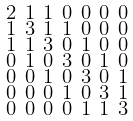<formula> <loc_0><loc_0><loc_500><loc_500>\begin{smallmatrix} 2 & 1 & 1 & 0 & 0 & 0 & 0 \\ 1 & 3 & 1 & 1 & 0 & 0 & 0 \\ 1 & 1 & 3 & 0 & 1 & 0 & 0 \\ 0 & 1 & 0 & 3 & 0 & 1 & 0 \\ 0 & 0 & 1 & 0 & 3 & 0 & 1 \\ 0 & 0 & 0 & 1 & 0 & 3 & 1 \\ 0 & 0 & 0 & 0 & 1 & 1 & 3 \end{smallmatrix}</formula> 